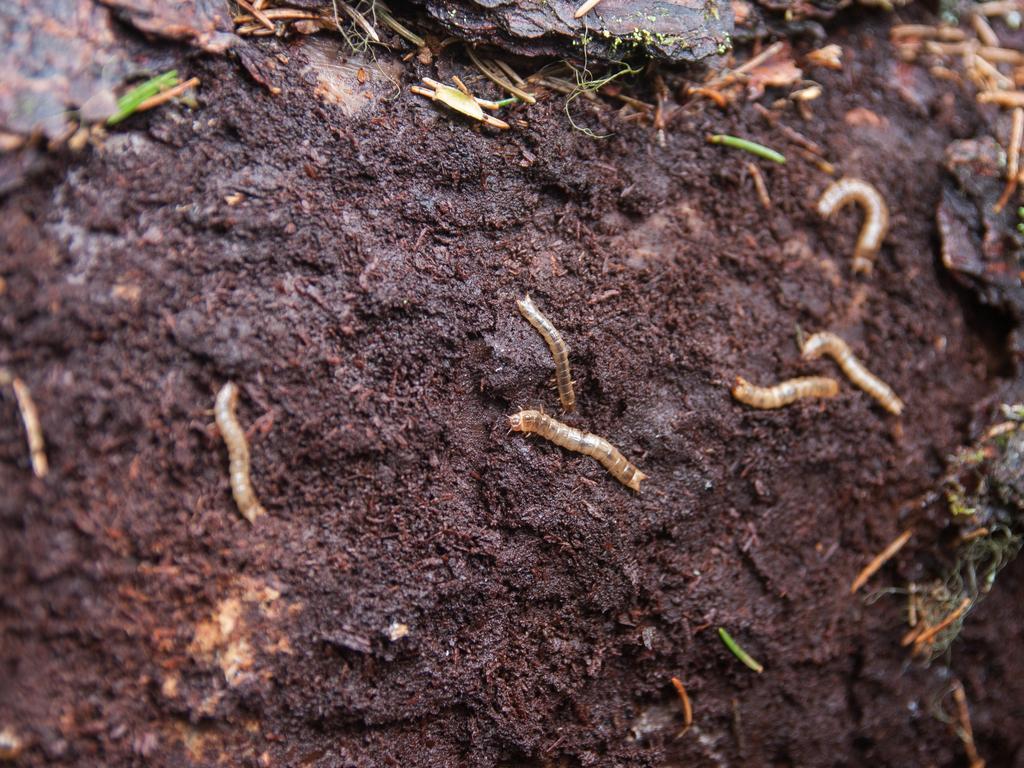Can you describe this image briefly? It seems to be the soil. On this there are many worms. 